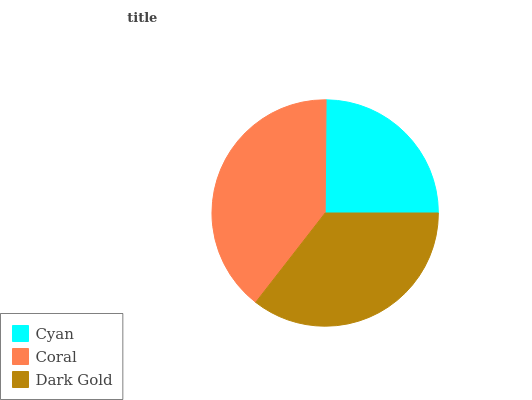Is Cyan the minimum?
Answer yes or no. Yes. Is Coral the maximum?
Answer yes or no. Yes. Is Dark Gold the minimum?
Answer yes or no. No. Is Dark Gold the maximum?
Answer yes or no. No. Is Coral greater than Dark Gold?
Answer yes or no. Yes. Is Dark Gold less than Coral?
Answer yes or no. Yes. Is Dark Gold greater than Coral?
Answer yes or no. No. Is Coral less than Dark Gold?
Answer yes or no. No. Is Dark Gold the high median?
Answer yes or no. Yes. Is Dark Gold the low median?
Answer yes or no. Yes. Is Coral the high median?
Answer yes or no. No. Is Coral the low median?
Answer yes or no. No. 